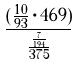<formula> <loc_0><loc_0><loc_500><loc_500>\frac { ( \frac { 1 0 } { 9 3 } \cdot 4 6 9 ) } { \frac { \frac { 7 } { 1 9 4 } } { 3 7 5 } }</formula> 